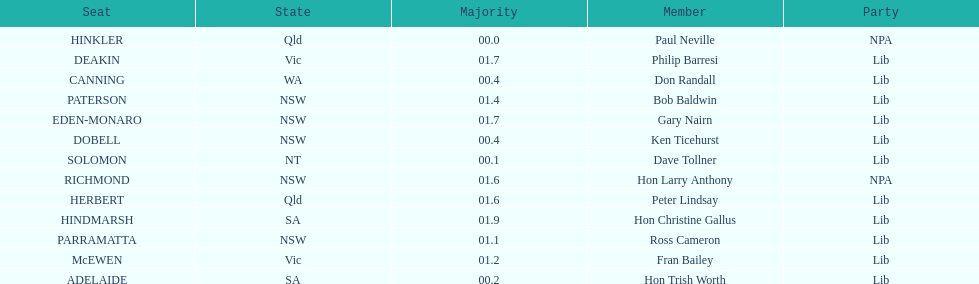What was the total majority that the dobell seat had? 00.4. 